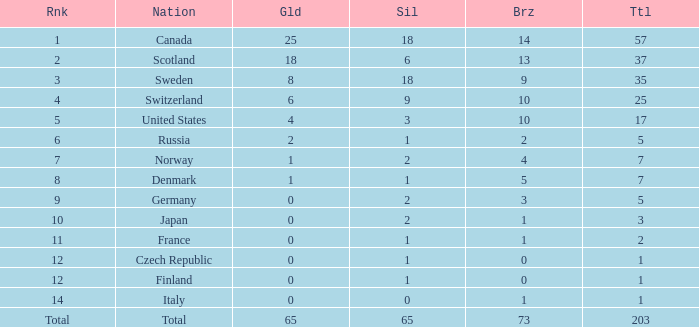What is the total number of medals when there are 18 gold medals? 37.0. Help me parse the entirety of this table. {'header': ['Rnk', 'Nation', 'Gld', 'Sil', 'Brz', 'Ttl'], 'rows': [['1', 'Canada', '25', '18', '14', '57'], ['2', 'Scotland', '18', '6', '13', '37'], ['3', 'Sweden', '8', '18', '9', '35'], ['4', 'Switzerland', '6', '9', '10', '25'], ['5', 'United States', '4', '3', '10', '17'], ['6', 'Russia', '2', '1', '2', '5'], ['7', 'Norway', '1', '2', '4', '7'], ['8', 'Denmark', '1', '1', '5', '7'], ['9', 'Germany', '0', '2', '3', '5'], ['10', 'Japan', '0', '2', '1', '3'], ['11', 'France', '0', '1', '1', '2'], ['12', 'Czech Republic', '0', '1', '0', '1'], ['12', 'Finland', '0', '1', '0', '1'], ['14', 'Italy', '0', '0', '1', '1'], ['Total', 'Total', '65', '65', '73', '203']]} 